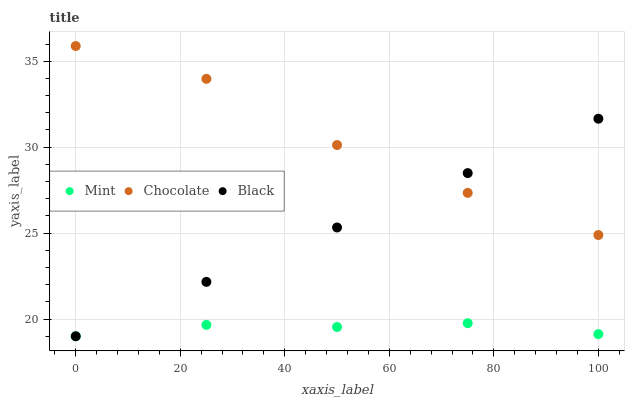Does Mint have the minimum area under the curve?
Answer yes or no. Yes. Does Chocolate have the maximum area under the curve?
Answer yes or no. Yes. Does Chocolate have the minimum area under the curve?
Answer yes or no. No. Does Mint have the maximum area under the curve?
Answer yes or no. No. Is Black the smoothest?
Answer yes or no. Yes. Is Chocolate the roughest?
Answer yes or no. Yes. Is Mint the smoothest?
Answer yes or no. No. Is Mint the roughest?
Answer yes or no. No. Does Black have the lowest value?
Answer yes or no. Yes. Does Chocolate have the lowest value?
Answer yes or no. No. Does Chocolate have the highest value?
Answer yes or no. Yes. Does Mint have the highest value?
Answer yes or no. No. Is Mint less than Chocolate?
Answer yes or no. Yes. Is Chocolate greater than Mint?
Answer yes or no. Yes. Does Mint intersect Black?
Answer yes or no. Yes. Is Mint less than Black?
Answer yes or no. No. Is Mint greater than Black?
Answer yes or no. No. Does Mint intersect Chocolate?
Answer yes or no. No. 